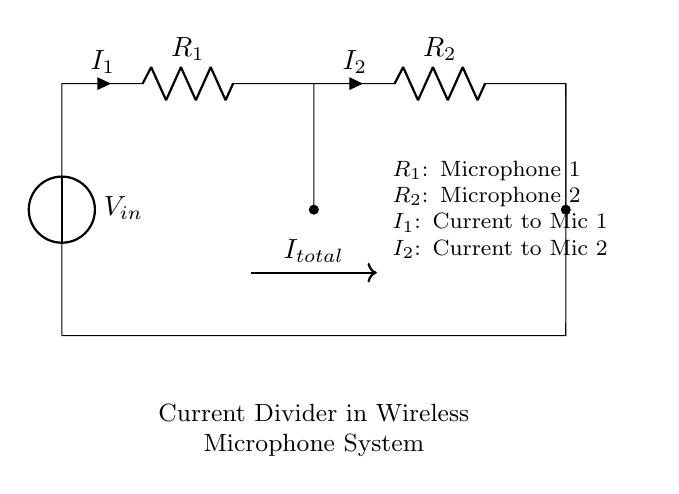What is the input voltage of this circuit? The input voltage is labeled as V_in in the circuit diagram. It represents the voltage supplied to the circuit.
Answer: V_in What are the two resistors in the circuit? The two resistors are labeled as R_1 and R_2. These represent the two microphones in the wireless microphone system.
Answer: R_1 and R_2 What is the total current entering the circuit? The total current is indicated by I_total in the diagram, which is the sum of the currents I_1 and I_2 flowing through the two resistors.
Answer: I_total Which microphone receives more current if R_1 has a lower resistance? If R_1 has a lower resistance than R_2, then according to the current divider principle, more current will flow through R_1 (I_1), meaning Microphone 1 will receive more current.
Answer: Microphone 1 How is the current divided between the two microphones? The current is divided based on the resistance values of R_1 and R_2. A lower resistance will draw more current. This follows the current divider rule: I_1 = I_total * (R_2 / (R_1 + R_2)) and I_2 = I_total * (R_1 / (R_1 + R_2)).
Answer: Based on resistance values What does I_1 represent in this circuit? I_1 represents the current flowing to Microphone 1. It is shown as an outgoing current from the node connected to R_1.
Answer: Current to Mic 1 